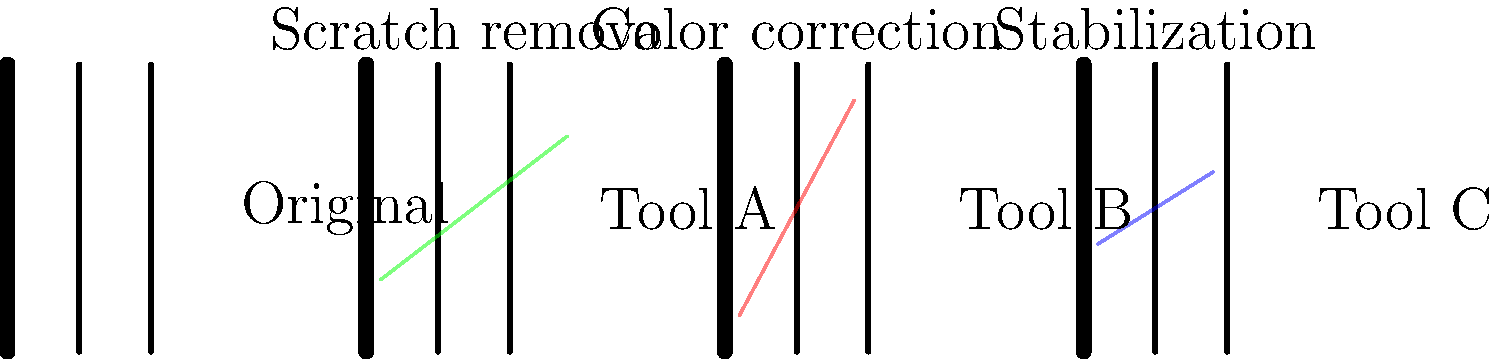Match the film restoration tools (A, B, C) to their corresponding effects on the sample film strips shown in the image above. To answer this question, we need to analyze the effects shown on each film strip and match them to common film restoration techniques:

1. Tool A: The green overlay shows a diagonal line being removed or filled in. This is indicative of scratch removal, a common issue in older film stocks.

2. Tool B: The red overlay covers a larger area of the film strip, suggesting a change in overall color or tone. This corresponds to color correction, which is used to restore faded colors or adjust color balance in old films.

3. Tool C: The blue overlay shows a horizontal shift or alignment of the film strip. This represents stabilization, which is used to reduce jitter or unsteady frames in film footage.

By understanding these visual representations and their corresponding restoration techniques, we can correctly match the tools to their effects.
Answer: A: Scratch removal, B: Color correction, C: Stabilization 